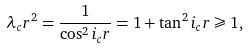<formula> <loc_0><loc_0><loc_500><loc_500>\lambda _ { c } r ^ { 2 } = \frac { 1 } { \cos ^ { 2 } i _ { c } r } = 1 + \tan ^ { 2 } i _ { c } r \geqslant 1 ,</formula> 